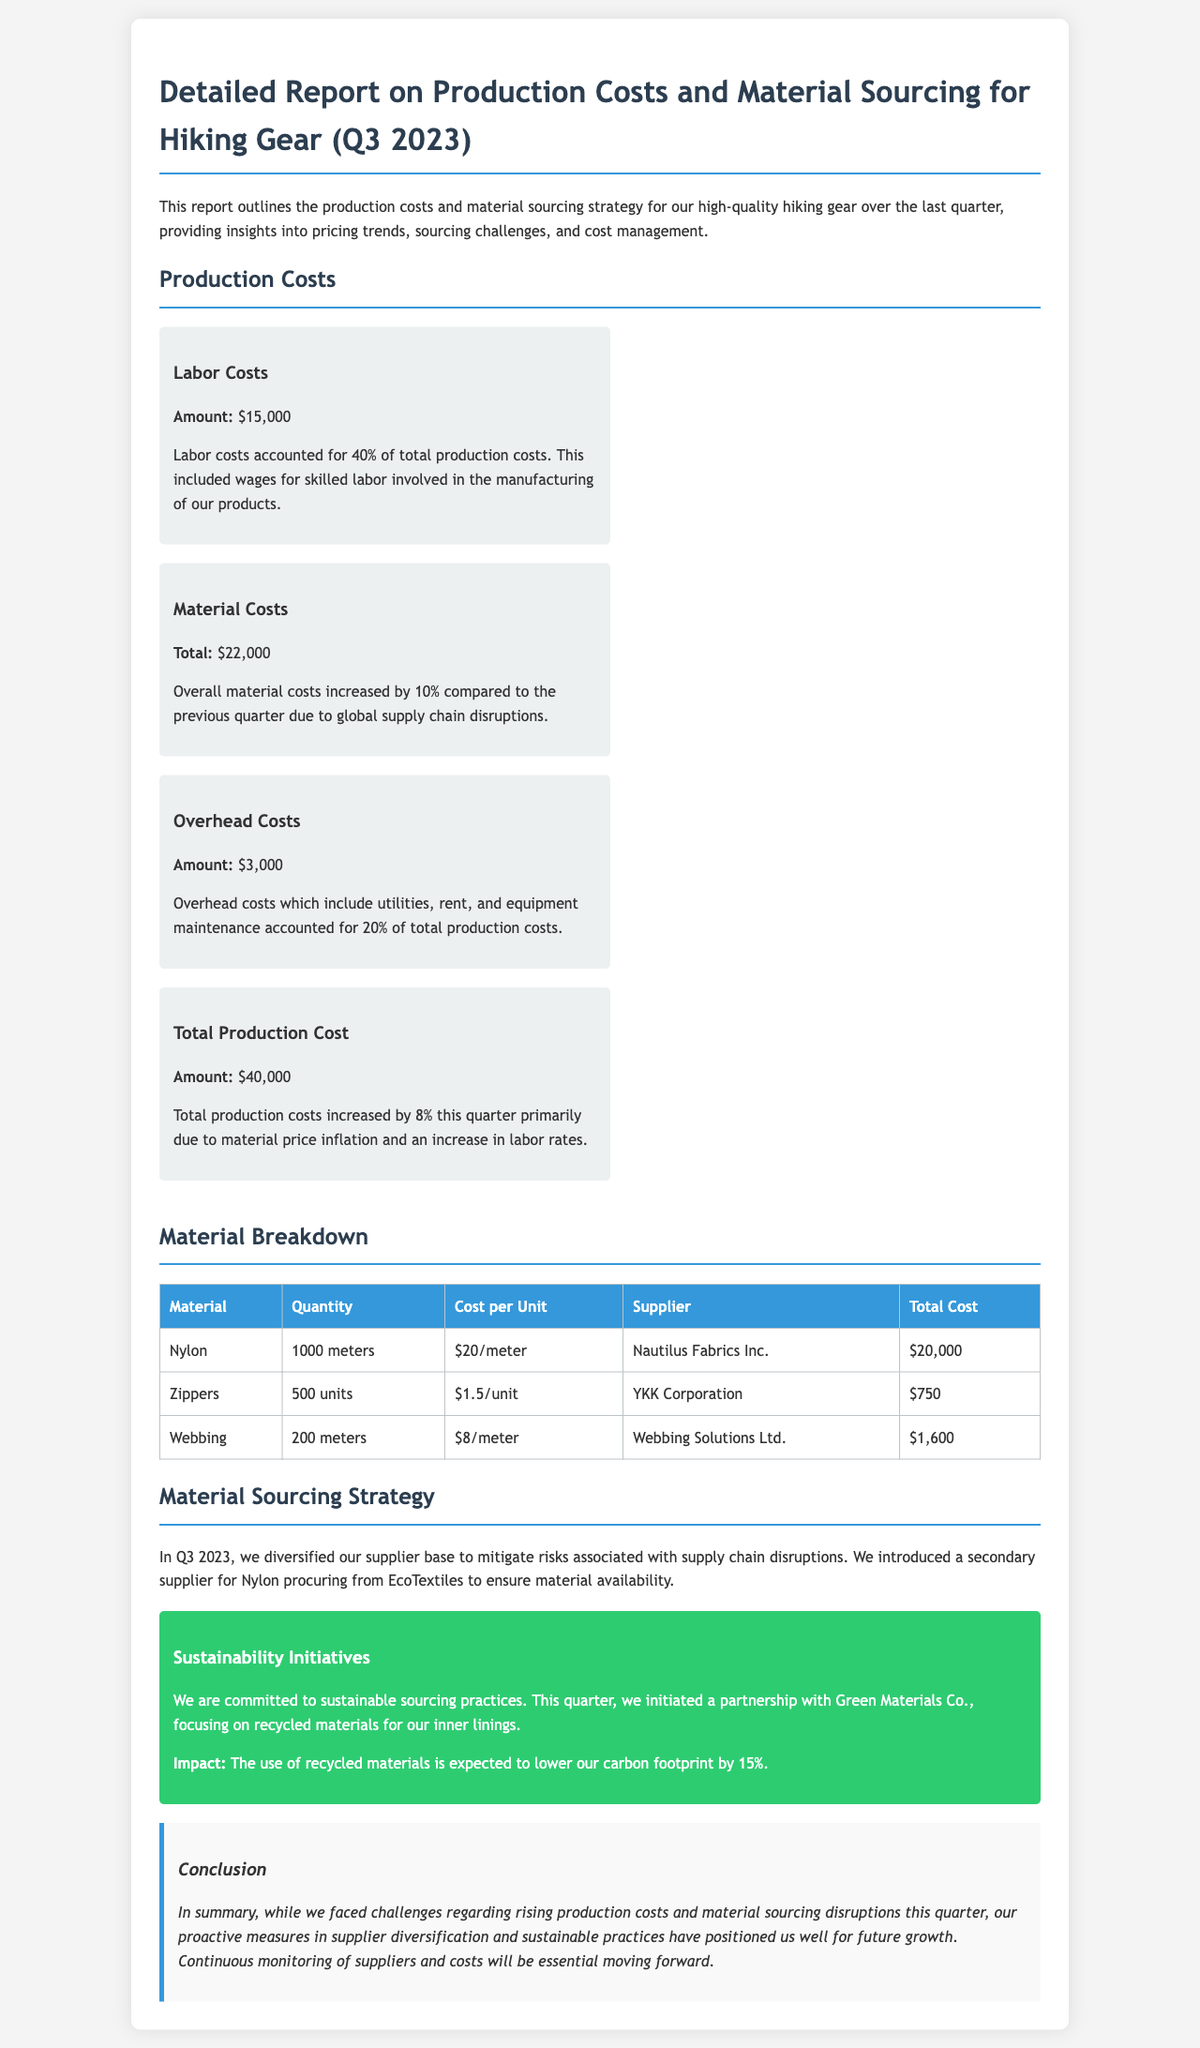What are the total labor costs? The total labor costs are specified in the report as $15,000.
Answer: $15,000 What percentage of total production costs do labor costs account for? The report states that labor costs accounted for 40% of the total production costs.
Answer: 40% What was the total production cost this quarter? The report lists the total production cost this quarter as $40,000.
Answer: $40,000 Which company supplied the nylon? The supplier for nylon is mentioned as Nautilus Fabrics Inc.
Answer: Nautilus Fabrics Inc What strategy was introduced to mitigate supply chain disruptions? The document indicates a secondary supplier for nylon was introduced to mitigate risks.
Answer: Secondary supplier How much did material costs increase compared to the previous quarter? The report states that overall material costs increased by 10%.
Answer: 10% What impact is expected from using recycled materials? The report notes that using recycled materials is expected to lower the carbon footprint by 15%.
Answer: 15% What do overhead costs include according to the report? Overhead costs include utilities, rent, and equipment maintenance as stated in the document.
Answer: Utilities, rent, maintenance What sustainable practice was initiated this quarter? A partnership with Green Materials Co. focusing on recycled materials was initiated.
Answer: Recycled materials partnership What were the total costs for zippers? The document specifies that the total cost for zippers was $750.
Answer: $750 